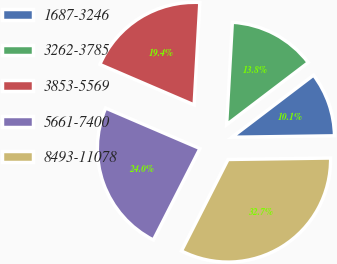Convert chart. <chart><loc_0><loc_0><loc_500><loc_500><pie_chart><fcel>1687-3246<fcel>3262-3785<fcel>3853-5569<fcel>5661-7400<fcel>8493-11078<nl><fcel>10.13%<fcel>13.76%<fcel>19.43%<fcel>23.96%<fcel>32.72%<nl></chart> 